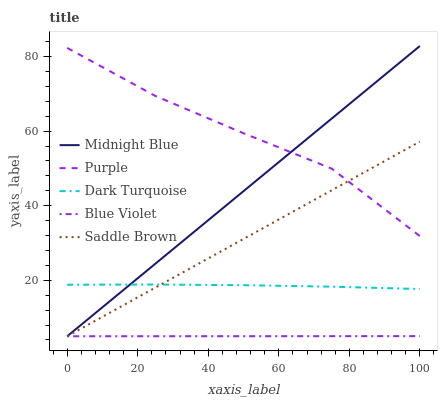Does Blue Violet have the minimum area under the curve?
Answer yes or no. Yes. Does Purple have the maximum area under the curve?
Answer yes or no. Yes. Does Dark Turquoise have the minimum area under the curve?
Answer yes or no. No. Does Dark Turquoise have the maximum area under the curve?
Answer yes or no. No. Is Midnight Blue the smoothest?
Answer yes or no. Yes. Is Purple the roughest?
Answer yes or no. Yes. Is Dark Turquoise the smoothest?
Answer yes or no. No. Is Dark Turquoise the roughest?
Answer yes or no. No. Does Midnight Blue have the lowest value?
Answer yes or no. Yes. Does Dark Turquoise have the lowest value?
Answer yes or no. No. Does Midnight Blue have the highest value?
Answer yes or no. Yes. Does Dark Turquoise have the highest value?
Answer yes or no. No. Is Blue Violet less than Dark Turquoise?
Answer yes or no. Yes. Is Purple greater than Blue Violet?
Answer yes or no. Yes. Does Purple intersect Midnight Blue?
Answer yes or no. Yes. Is Purple less than Midnight Blue?
Answer yes or no. No. Is Purple greater than Midnight Blue?
Answer yes or no. No. Does Blue Violet intersect Dark Turquoise?
Answer yes or no. No. 